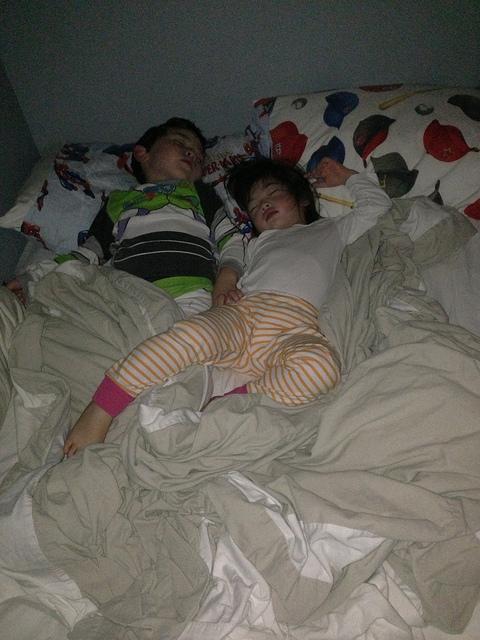How many people can be seen?
Give a very brief answer. 2. How many people are in the picture?
Give a very brief answer. 2. How many beds are there?
Give a very brief answer. 1. 